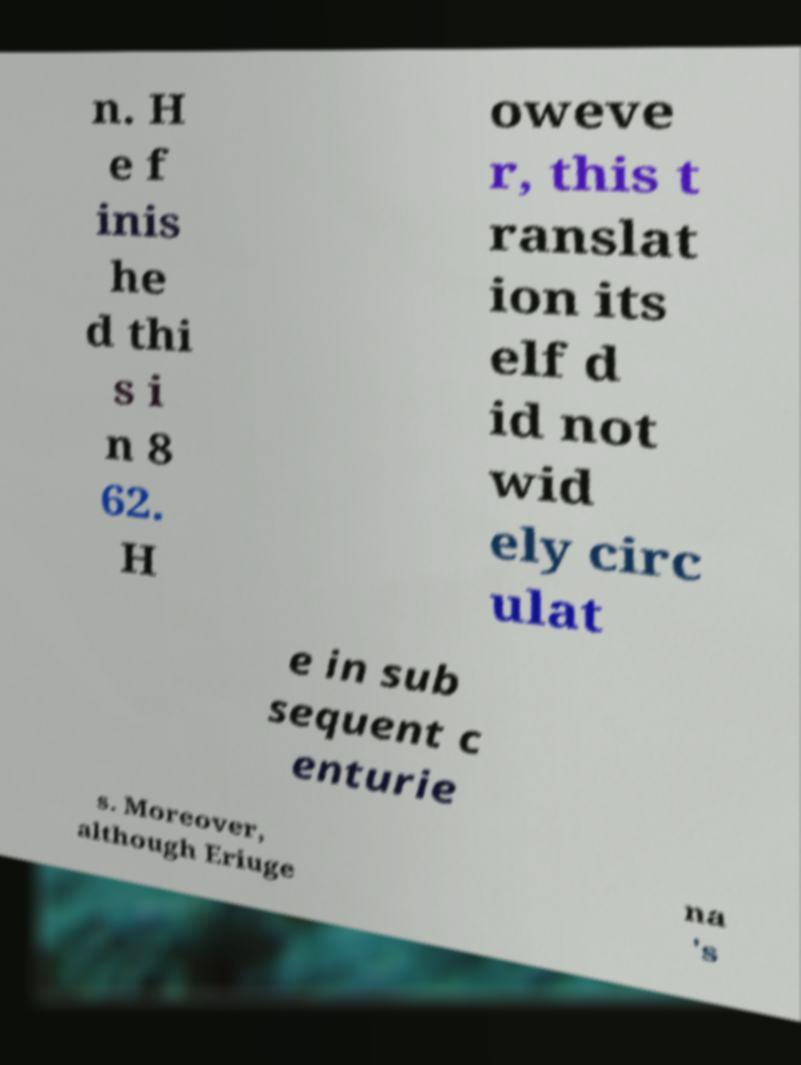Could you extract and type out the text from this image? n. H e f inis he d thi s i n 8 62. H oweve r, this t ranslat ion its elf d id not wid ely circ ulat e in sub sequent c enturie s. Moreover, although Eriuge na 's 